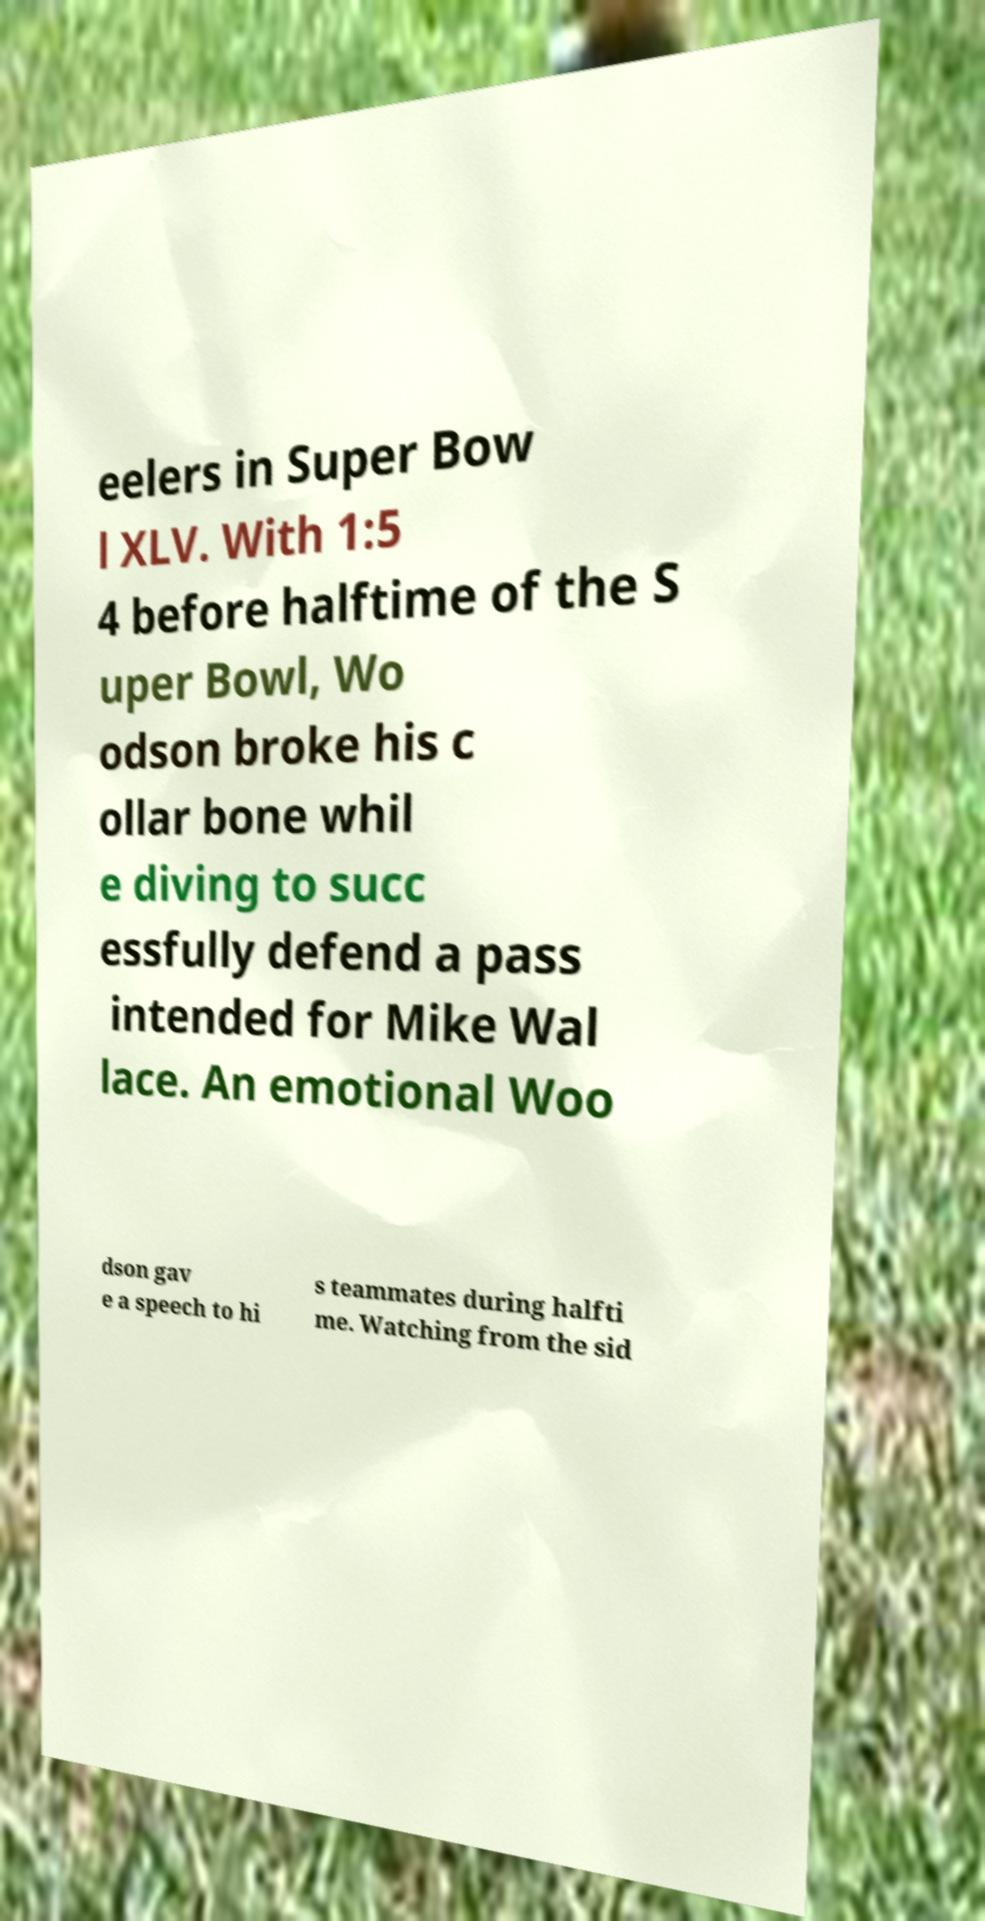For documentation purposes, I need the text within this image transcribed. Could you provide that? eelers in Super Bow l XLV. With 1:5 4 before halftime of the S uper Bowl, Wo odson broke his c ollar bone whil e diving to succ essfully defend a pass intended for Mike Wal lace. An emotional Woo dson gav e a speech to hi s teammates during halfti me. Watching from the sid 